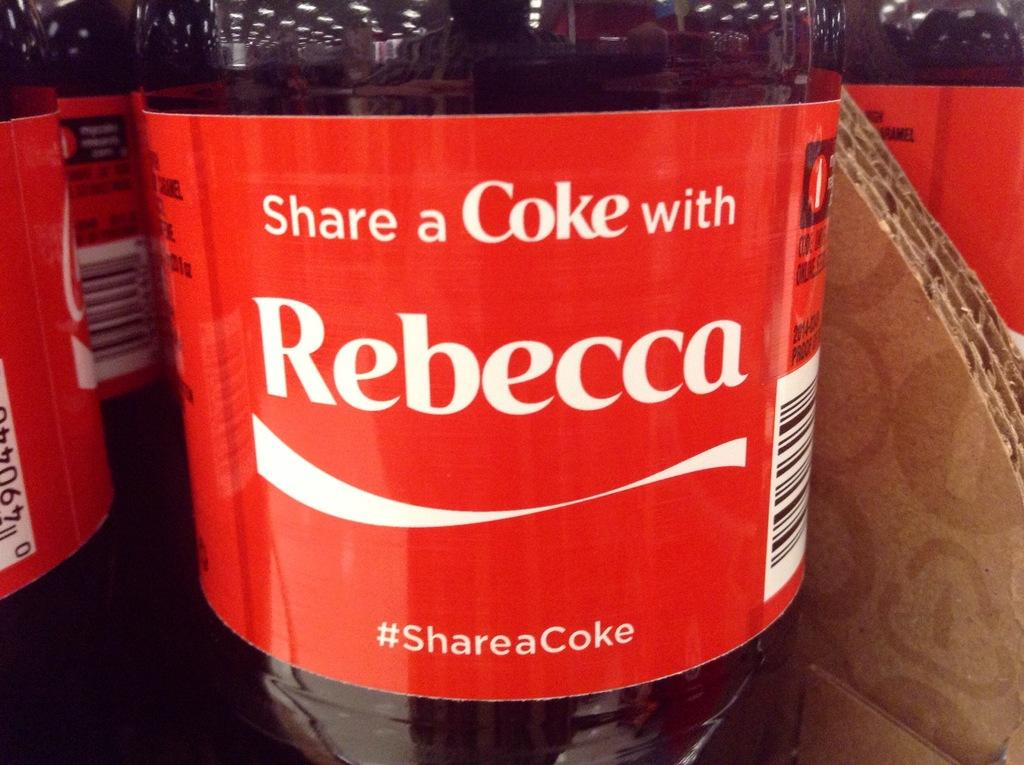What is the common feature of the objects in the image? The common feature of the objects in the image is that they are bottles. Who is associated with the bottles in the image? The bottles are associated with Rebecca Cooke. What type of liquid is present in at least one of the bottles? There is a coke in at least one of the bottles. What is the material of the object beside one of the bottles? There is a cardboard beside one of the bottles. What type of toothbrush is used by the robin in the image? There is no robin or toothbrush present in the image. 